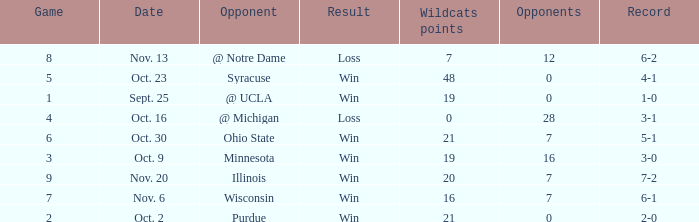What is the lowest points scored by the Wildcats when the record was 5-1? 21.0. 